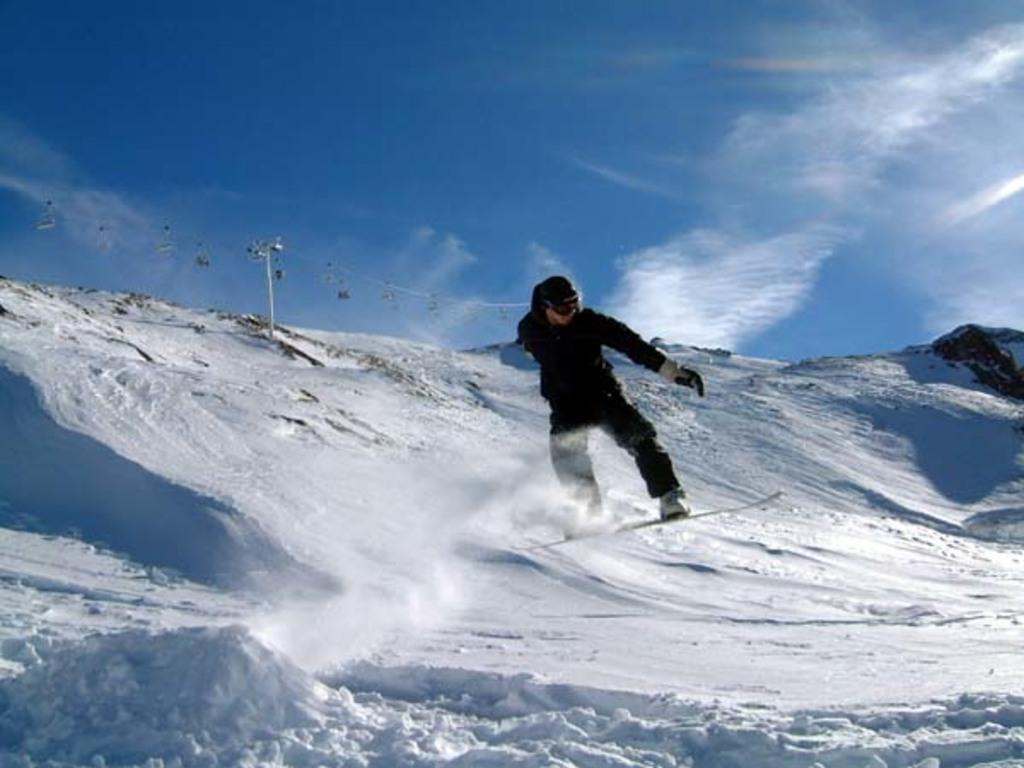What is the person in the image doing? There is a person on a skateboard in the image. What is the condition of the ground in the image? The ground is covered with snow. What can be seen attached to the pole in the image? There is a pole with a wire in the image, and there are some objects associated with the pole and wire. What is visible in the background of the image? The sky is visible in the image. How many books can be seen stacked on the potato in the image? There are no books or potatoes present in the image. 